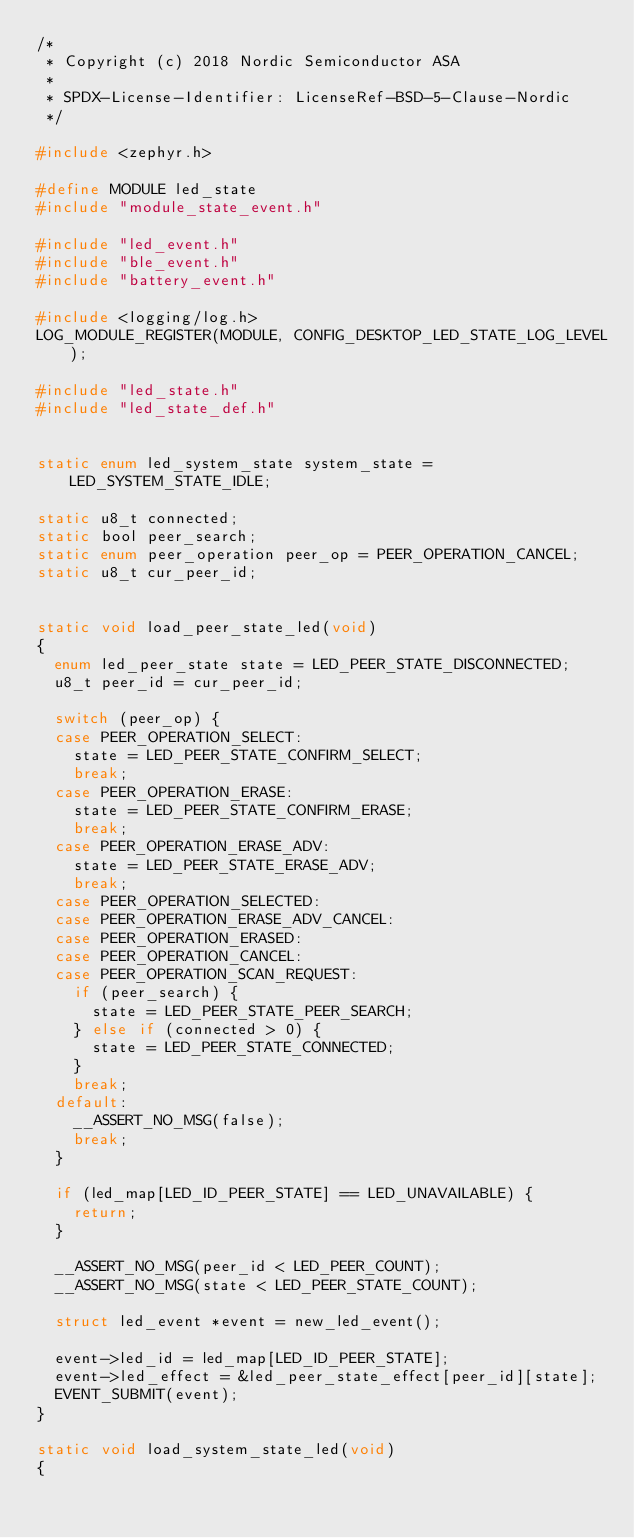Convert code to text. <code><loc_0><loc_0><loc_500><loc_500><_C_>/*
 * Copyright (c) 2018 Nordic Semiconductor ASA
 *
 * SPDX-License-Identifier: LicenseRef-BSD-5-Clause-Nordic
 */

#include <zephyr.h>

#define MODULE led_state
#include "module_state_event.h"

#include "led_event.h"
#include "ble_event.h"
#include "battery_event.h"

#include <logging/log.h>
LOG_MODULE_REGISTER(MODULE, CONFIG_DESKTOP_LED_STATE_LOG_LEVEL);

#include "led_state.h"
#include "led_state_def.h"


static enum led_system_state system_state = LED_SYSTEM_STATE_IDLE;

static u8_t connected;
static bool peer_search;
static enum peer_operation peer_op = PEER_OPERATION_CANCEL;
static u8_t cur_peer_id;


static void load_peer_state_led(void)
{
	enum led_peer_state state = LED_PEER_STATE_DISCONNECTED;
	u8_t peer_id = cur_peer_id;

	switch (peer_op) {
	case PEER_OPERATION_SELECT:
		state = LED_PEER_STATE_CONFIRM_SELECT;
		break;
	case PEER_OPERATION_ERASE:
		state = LED_PEER_STATE_CONFIRM_ERASE;
		break;
	case PEER_OPERATION_ERASE_ADV:
		state = LED_PEER_STATE_ERASE_ADV;
		break;
	case PEER_OPERATION_SELECTED:
	case PEER_OPERATION_ERASE_ADV_CANCEL:
	case PEER_OPERATION_ERASED:
	case PEER_OPERATION_CANCEL:
	case PEER_OPERATION_SCAN_REQUEST:
		if (peer_search) {
			state = LED_PEER_STATE_PEER_SEARCH;
		} else if (connected > 0) {
			state = LED_PEER_STATE_CONNECTED;
		}
		break;
	default:
		__ASSERT_NO_MSG(false);
		break;
	}

	if (led_map[LED_ID_PEER_STATE] == LED_UNAVAILABLE) {
		return;
	}

	__ASSERT_NO_MSG(peer_id < LED_PEER_COUNT);
	__ASSERT_NO_MSG(state < LED_PEER_STATE_COUNT);

	struct led_event *event = new_led_event();

	event->led_id = led_map[LED_ID_PEER_STATE];
	event->led_effect = &led_peer_state_effect[peer_id][state];
	EVENT_SUBMIT(event);
}

static void load_system_state_led(void)
{</code> 